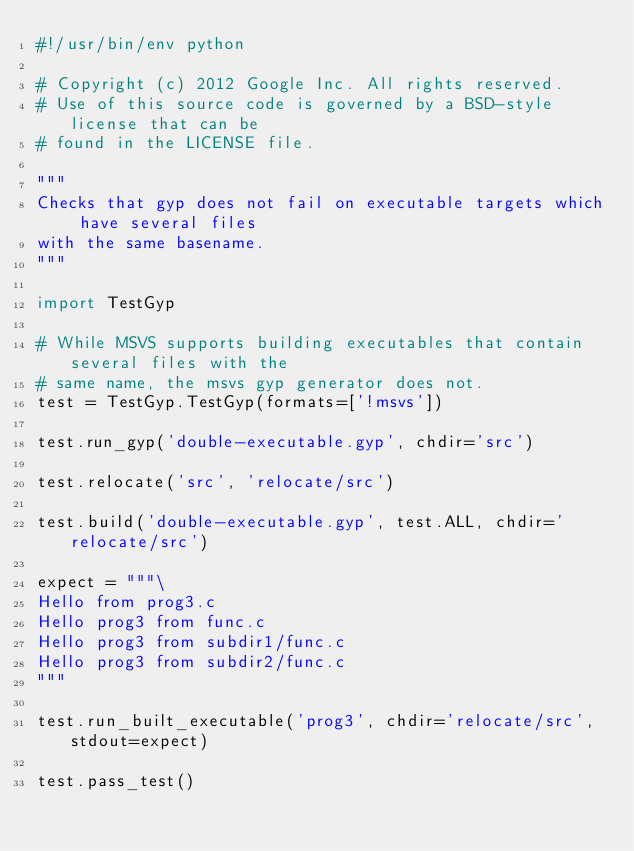<code> <loc_0><loc_0><loc_500><loc_500><_Python_>#!/usr/bin/env python

# Copyright (c) 2012 Google Inc. All rights reserved.
# Use of this source code is governed by a BSD-style license that can be
# found in the LICENSE file.

"""
Checks that gyp does not fail on executable targets which have several files
with the same basename.
"""

import TestGyp

# While MSVS supports building executables that contain several files with the
# same name, the msvs gyp generator does not.
test = TestGyp.TestGyp(formats=['!msvs'])

test.run_gyp('double-executable.gyp', chdir='src')

test.relocate('src', 'relocate/src')

test.build('double-executable.gyp', test.ALL, chdir='relocate/src')

expect = """\
Hello from prog3.c
Hello prog3 from func.c
Hello prog3 from subdir1/func.c
Hello prog3 from subdir2/func.c
"""

test.run_built_executable('prog3', chdir='relocate/src', stdout=expect)

test.pass_test()
</code> 